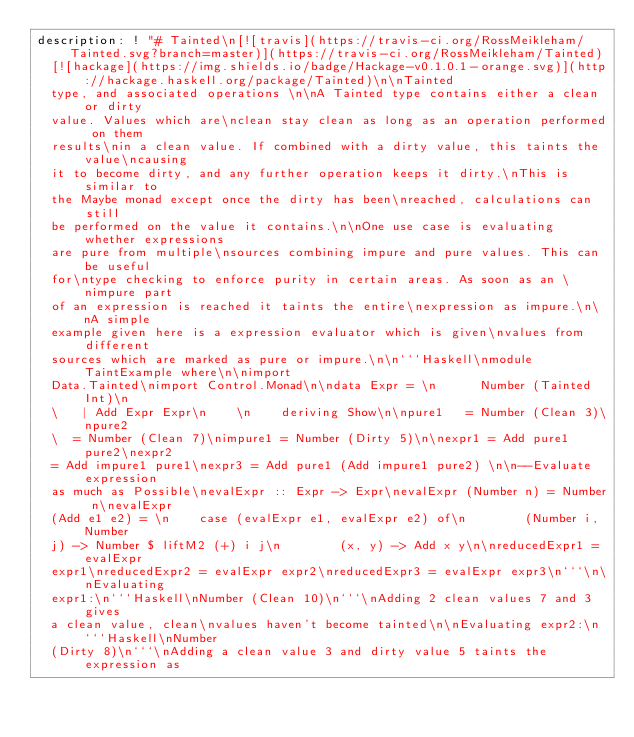<code> <loc_0><loc_0><loc_500><loc_500><_YAML_>description: ! "# Tainted\n[![travis](https://travis-ci.org/RossMeikleham/Tainted.svg?branch=master)](https://travis-ci.org/RossMeikleham/Tainted)
  [![hackage](https://img.shields.io/badge/Hackage-v0.1.0.1-orange.svg)](http://hackage.haskell.org/package/Tainted)\n\nTainted
  type, and associated operations \n\nA Tainted type contains either a clean or dirty
  value. Values which are\nclean stay clean as long as an operation performed on them
  results\nin a clean value. If combined with a dirty value, this taints the value\ncausing
  it to become dirty, and any further operation keeps it dirty.\nThis is similar to
  the Maybe monad except once the dirty has been\nreached, calculations can still
  be performed on the value it contains.\n\nOne use case is evaluating whether expressions
  are pure from multiple\nsources combining impure and pure values. This can be useful
  for\ntype checking to enforce purity in certain areas. As soon as an \nimpure part
  of an expression is reached it taints the entire\nexpression as impure.\n\nA simple
  example given here is a expression evaluator which is given\nvalues from different
  sources which are marked as pure or impure.\n\n```Haskell\nmodule TaintExample where\n\nimport
  Data.Tainted\nimport Control.Monad\n\ndata Expr = \n      Number (Tainted Int)\n
  \   | Add Expr Expr\n    \n    deriving Show\n\npure1   = Number (Clean 3)\npure2
  \  = Number (Clean 7)\nimpure1 = Number (Dirty 5)\n\nexpr1 = Add pure1 pure2\nexpr2
  = Add impure1 pure1\nexpr3 = Add pure1 (Add impure1 pure2) \n\n--Evaluate expression
  as much as Possible\nevalExpr :: Expr -> Expr\nevalExpr (Number n) = Number n\nevalExpr
  (Add e1 e2) = \n    case (evalExpr e1, evalExpr e2) of\n        (Number i, Number
  j) -> Number $ liftM2 (+) i j\n        (x, y) -> Add x y\n\nreducedExpr1 = evalExpr
  expr1\nreducedExpr2 = evalExpr expr2\nreducedExpr3 = evalExpr expr3\n```\n\nEvaluating
  expr1:\n```Haskell\nNumber (Clean 10)\n```\nAdding 2 clean values 7 and 3 gives
  a clean value, clean\nvalues haven't become tainted\n\nEvaluating expr2:\n```Haskell\nNumber
  (Dirty 8)\n```\nAdding a clean value 3 and dirty value 5 taints the expression as</code> 